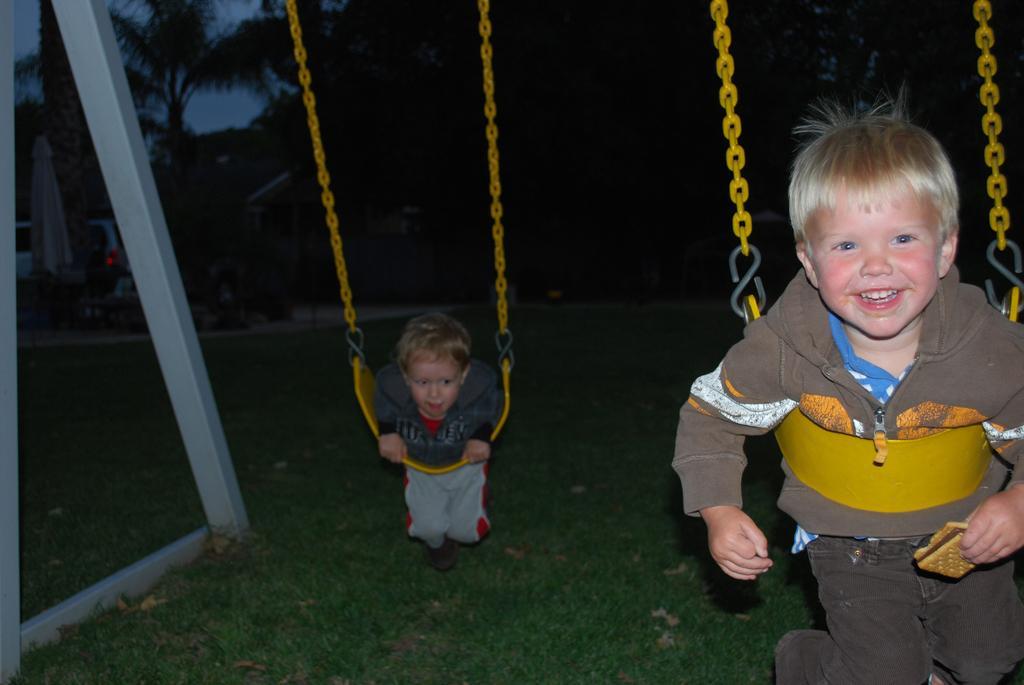Please provide a concise description of this image. In this image I can see two children are on the swings which are yellow in color. I can see some grass on the ground, a vehicle , few trees and the sky in the background. 